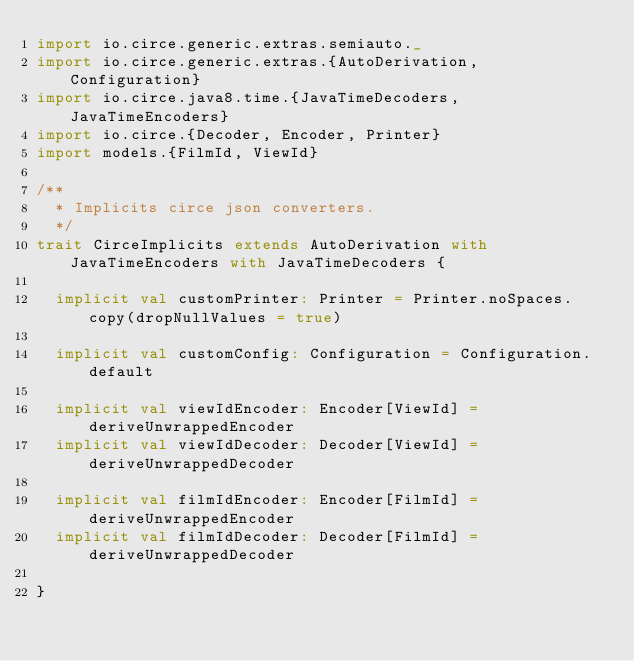Convert code to text. <code><loc_0><loc_0><loc_500><loc_500><_Scala_>import io.circe.generic.extras.semiauto._
import io.circe.generic.extras.{AutoDerivation, Configuration}
import io.circe.java8.time.{JavaTimeDecoders, JavaTimeEncoders}
import io.circe.{Decoder, Encoder, Printer}
import models.{FilmId, ViewId}

/**
  * Implicits circe json converters.
  */
trait CirceImplicits extends AutoDerivation with JavaTimeEncoders with JavaTimeDecoders {

  implicit val customPrinter: Printer = Printer.noSpaces.copy(dropNullValues = true)

  implicit val customConfig: Configuration = Configuration.default

  implicit val viewIdEncoder: Encoder[ViewId] = deriveUnwrappedEncoder
  implicit val viewIdDecoder: Decoder[ViewId] = deriveUnwrappedDecoder

  implicit val filmIdEncoder: Encoder[FilmId] = deriveUnwrappedEncoder
  implicit val filmIdDecoder: Decoder[FilmId] = deriveUnwrappedDecoder

}
</code> 